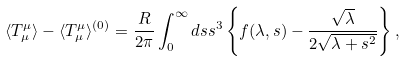Convert formula to latex. <formula><loc_0><loc_0><loc_500><loc_500>\langle T ^ { \mu } _ { \mu } \rangle - \langle T ^ { \mu } _ { \mu } \rangle ^ { ( 0 ) } = \frac { R } { 2 \pi } \int _ { 0 } ^ { \infty } d s s ^ { 3 } \left \{ f ( \lambda , s ) - \frac { \sqrt { \lambda } } { 2 \sqrt { \lambda + s ^ { 2 } } } \right \} ,</formula> 